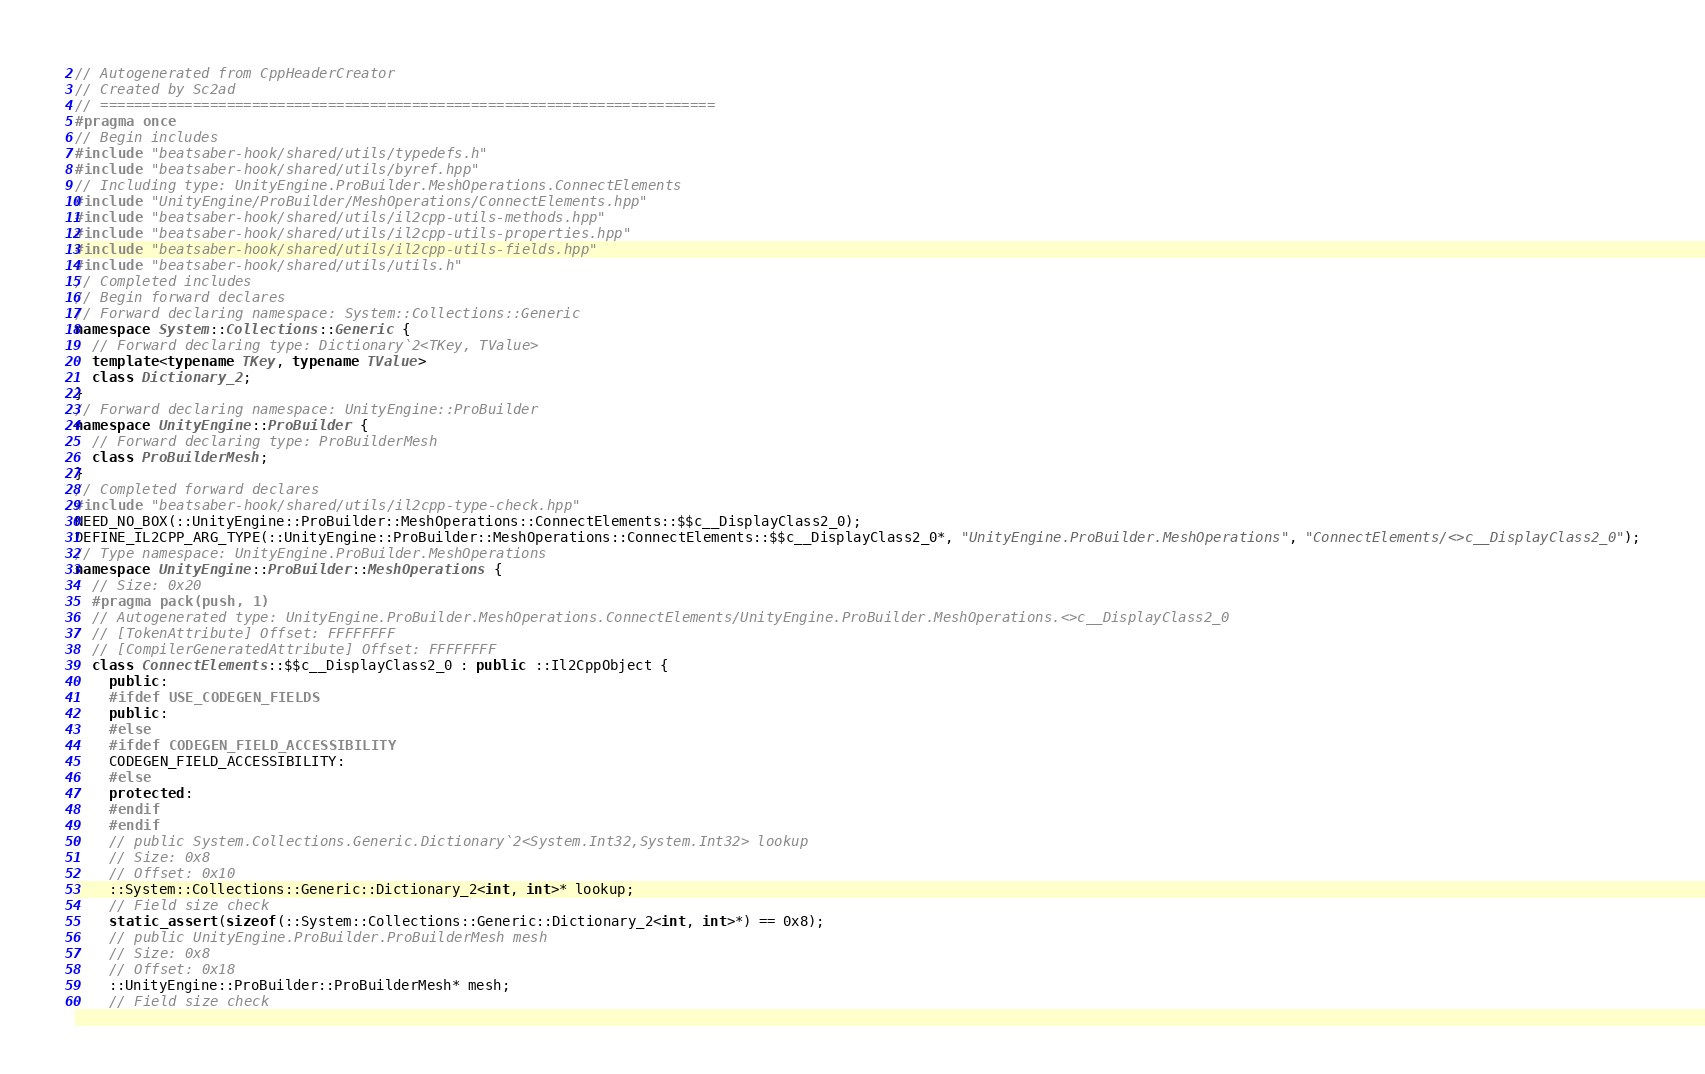<code> <loc_0><loc_0><loc_500><loc_500><_C++_>// Autogenerated from CppHeaderCreator
// Created by Sc2ad
// =========================================================================
#pragma once
// Begin includes
#include "beatsaber-hook/shared/utils/typedefs.h"
#include "beatsaber-hook/shared/utils/byref.hpp"
// Including type: UnityEngine.ProBuilder.MeshOperations.ConnectElements
#include "UnityEngine/ProBuilder/MeshOperations/ConnectElements.hpp"
#include "beatsaber-hook/shared/utils/il2cpp-utils-methods.hpp"
#include "beatsaber-hook/shared/utils/il2cpp-utils-properties.hpp"
#include "beatsaber-hook/shared/utils/il2cpp-utils-fields.hpp"
#include "beatsaber-hook/shared/utils/utils.h"
// Completed includes
// Begin forward declares
// Forward declaring namespace: System::Collections::Generic
namespace System::Collections::Generic {
  // Forward declaring type: Dictionary`2<TKey, TValue>
  template<typename TKey, typename TValue>
  class Dictionary_2;
}
// Forward declaring namespace: UnityEngine::ProBuilder
namespace UnityEngine::ProBuilder {
  // Forward declaring type: ProBuilderMesh
  class ProBuilderMesh;
}
// Completed forward declares
#include "beatsaber-hook/shared/utils/il2cpp-type-check.hpp"
NEED_NO_BOX(::UnityEngine::ProBuilder::MeshOperations::ConnectElements::$$c__DisplayClass2_0);
DEFINE_IL2CPP_ARG_TYPE(::UnityEngine::ProBuilder::MeshOperations::ConnectElements::$$c__DisplayClass2_0*, "UnityEngine.ProBuilder.MeshOperations", "ConnectElements/<>c__DisplayClass2_0");
// Type namespace: UnityEngine.ProBuilder.MeshOperations
namespace UnityEngine::ProBuilder::MeshOperations {
  // Size: 0x20
  #pragma pack(push, 1)
  // Autogenerated type: UnityEngine.ProBuilder.MeshOperations.ConnectElements/UnityEngine.ProBuilder.MeshOperations.<>c__DisplayClass2_0
  // [TokenAttribute] Offset: FFFFFFFF
  // [CompilerGeneratedAttribute] Offset: FFFFFFFF
  class ConnectElements::$$c__DisplayClass2_0 : public ::Il2CppObject {
    public:
    #ifdef USE_CODEGEN_FIELDS
    public:
    #else
    #ifdef CODEGEN_FIELD_ACCESSIBILITY
    CODEGEN_FIELD_ACCESSIBILITY:
    #else
    protected:
    #endif
    #endif
    // public System.Collections.Generic.Dictionary`2<System.Int32,System.Int32> lookup
    // Size: 0x8
    // Offset: 0x10
    ::System::Collections::Generic::Dictionary_2<int, int>* lookup;
    // Field size check
    static_assert(sizeof(::System::Collections::Generic::Dictionary_2<int, int>*) == 0x8);
    // public UnityEngine.ProBuilder.ProBuilderMesh mesh
    // Size: 0x8
    // Offset: 0x18
    ::UnityEngine::ProBuilder::ProBuilderMesh* mesh;
    // Field size check</code> 